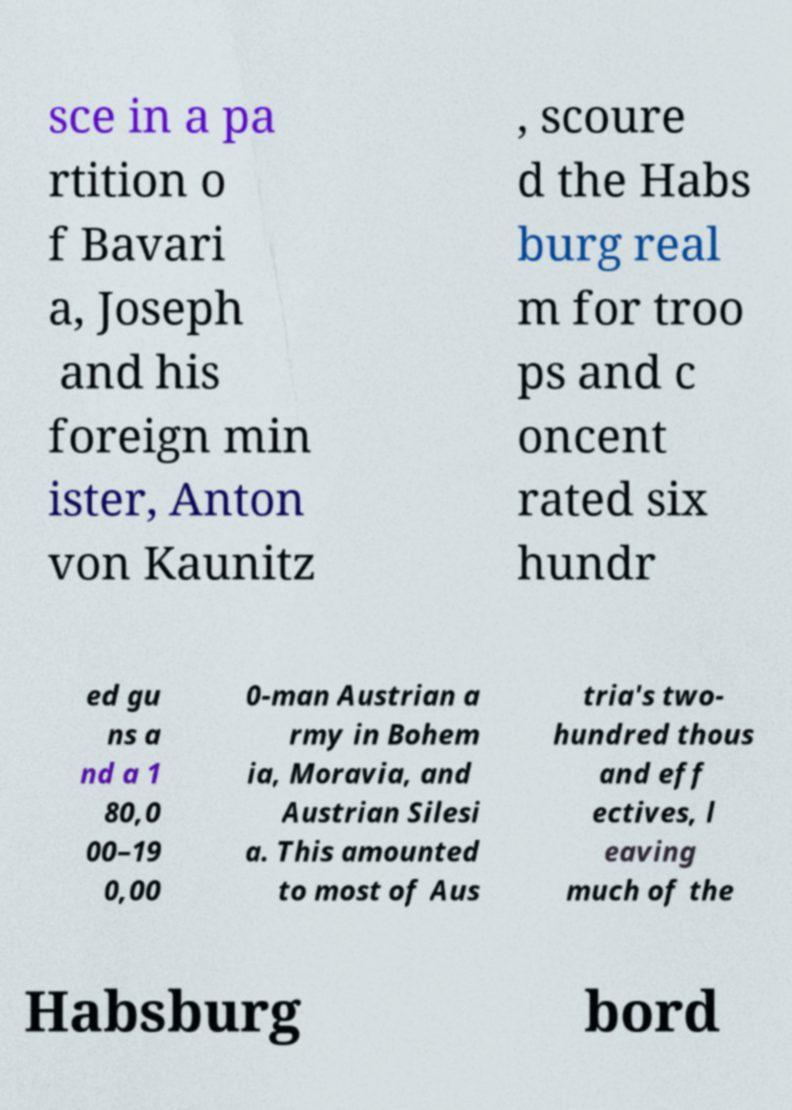Can you read and provide the text displayed in the image?This photo seems to have some interesting text. Can you extract and type it out for me? sce in a pa rtition o f Bavari a, Joseph and his foreign min ister, Anton von Kaunitz , scoure d the Habs burg real m for troo ps and c oncent rated six hundr ed gu ns a nd a 1 80,0 00–19 0,00 0-man Austrian a rmy in Bohem ia, Moravia, and Austrian Silesi a. This amounted to most of Aus tria's two- hundred thous and eff ectives, l eaving much of the Habsburg bord 